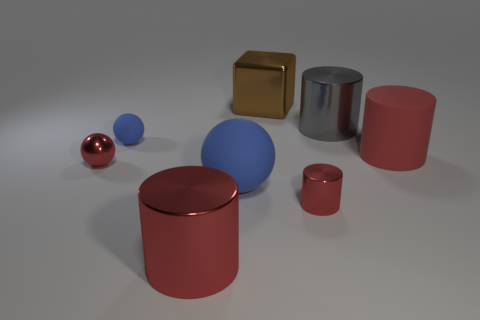Are there any balls of the same color as the tiny matte thing?
Your response must be concise. Yes. There is a rubber thing that is the same color as the tiny shiny sphere; what size is it?
Provide a succinct answer. Large. There is a big shiny object in front of the large rubber sphere; what shape is it?
Make the answer very short. Cylinder. Are there any small red cylinders made of the same material as the red ball?
Give a very brief answer. Yes. Does the brown cube have the same size as the gray metal cylinder?
Keep it short and to the point. Yes. How many cylinders are either tiny red things or brown metal objects?
Ensure brevity in your answer.  1. What is the material of the other sphere that is the same color as the tiny matte sphere?
Offer a very short reply. Rubber. How many large red metallic things are the same shape as the big red matte object?
Provide a short and direct response. 1. Is the number of cubes that are left of the big blue rubber thing greater than the number of tiny things behind the small red metallic sphere?
Give a very brief answer. No. There is a cylinder to the left of the small red cylinder; is its color the same as the tiny metal cylinder?
Make the answer very short. Yes. 